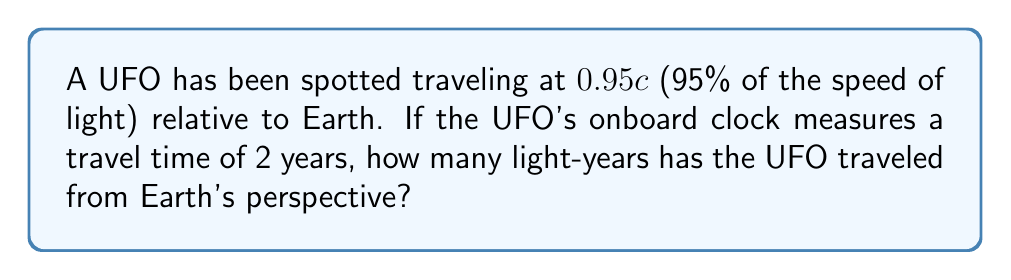Can you solve this math problem? Let's approach this step-by-step using special relativity:

1) First, we need to calculate the Lorentz factor (γ) for the UFO:

   $$\gamma = \frac{1}{\sqrt{1-v^2/c^2}}$$

   Where v = 0.95c

2) Plugging in the values:

   $$\gamma = \frac{1}{\sqrt{1-(0.95)^2}} \approx 3.2026$$

3) Now, we can use the time dilation formula:

   $$t_{Earth} = \gamma \cdot t_{UFO}$$

   Where $t_{UFO}$ = 2 years

4) Calculating Earth time:

   $$t_{Earth} = 3.2026 \cdot 2 = 6.4052 \text{ years}$$

5) To find the distance traveled from Earth's perspective, we use:

   $$d = v \cdot t_{Earth}$$

6) Plugging in the values:

   $$d = 0.95c \cdot 6.4052 \text{ years}$$

7) Simplifying:

   $$d = 6.08494 \text{ light-years}$$

Thus, from Earth's perspective, the UFO has traveled about 6.08 light-years.
Answer: 6.08 light-years 